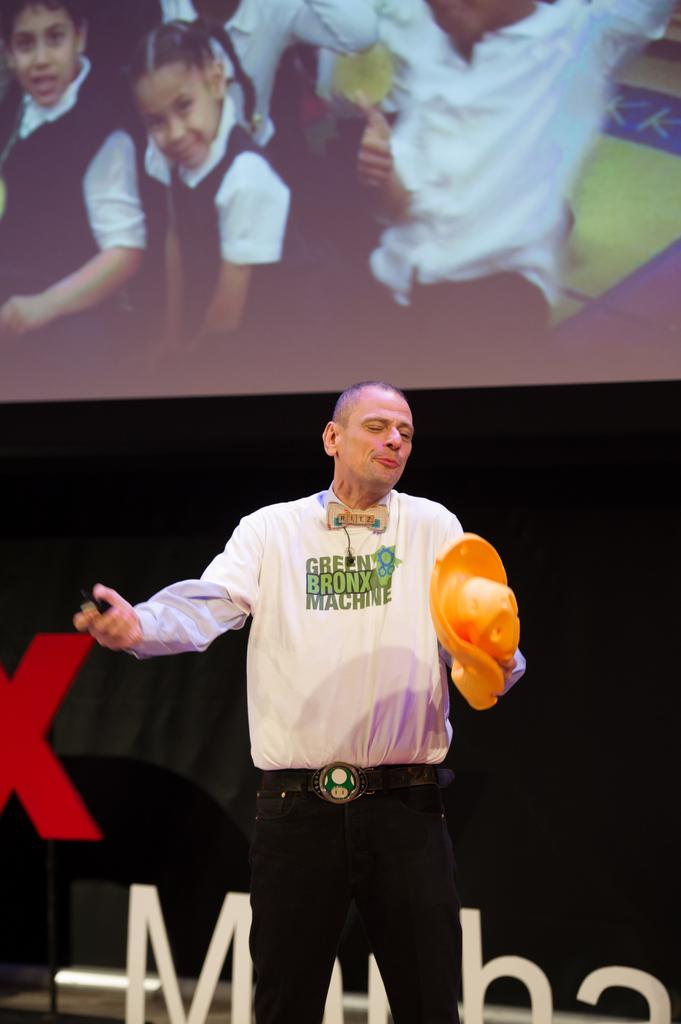What is the person wearing in the image? The person is wearing a white dress in the image. What is the person doing in the image? The person is standing in the image. What is the person holding in their hand in the image? The person is holding an orange object in their hand in the image. What can be seen in the background of the image? There is a picture of kids displayed in the image. Where is the market located in the image? There is no market present in the image. What type of paper is the person holding in their hand in the image? The person is not holding any paper in their hand in the image; they are holding an orange object. 